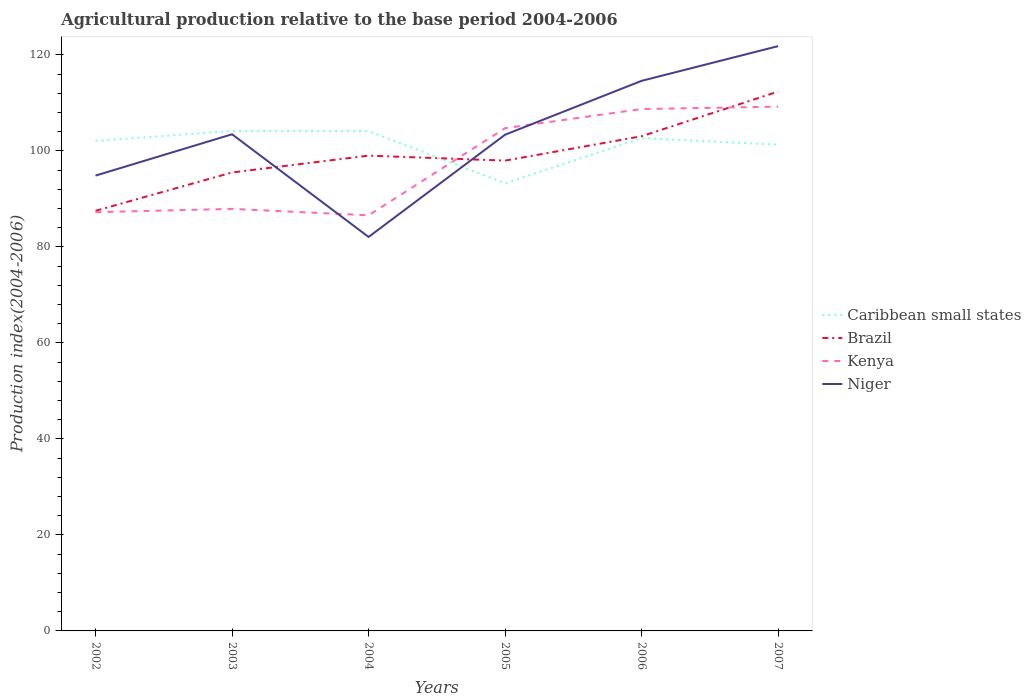How many different coloured lines are there?
Offer a terse response. 4. Across all years, what is the maximum agricultural production index in Brazil?
Offer a very short reply. 87.51. What is the total agricultural production index in Brazil in the graph?
Make the answer very short. -7.55. What is the difference between the highest and the second highest agricultural production index in Brazil?
Ensure brevity in your answer.  24.84. What is the difference between the highest and the lowest agricultural production index in Kenya?
Your answer should be compact. 3. Does the graph contain any zero values?
Offer a very short reply. No. How many legend labels are there?
Keep it short and to the point. 4. How are the legend labels stacked?
Provide a short and direct response. Vertical. What is the title of the graph?
Your answer should be compact. Agricultural production relative to the base period 2004-2006. Does "Burkina Faso" appear as one of the legend labels in the graph?
Offer a very short reply. No. What is the label or title of the Y-axis?
Give a very brief answer. Production index(2004-2006). What is the Production index(2004-2006) in Caribbean small states in 2002?
Provide a succinct answer. 102.07. What is the Production index(2004-2006) of Brazil in 2002?
Provide a short and direct response. 87.51. What is the Production index(2004-2006) in Kenya in 2002?
Provide a short and direct response. 87.22. What is the Production index(2004-2006) in Niger in 2002?
Give a very brief answer. 94.84. What is the Production index(2004-2006) of Caribbean small states in 2003?
Offer a terse response. 104.13. What is the Production index(2004-2006) of Brazil in 2003?
Make the answer very short. 95.49. What is the Production index(2004-2006) in Kenya in 2003?
Your answer should be very brief. 87.91. What is the Production index(2004-2006) in Niger in 2003?
Give a very brief answer. 103.45. What is the Production index(2004-2006) in Caribbean small states in 2004?
Your answer should be compact. 104.11. What is the Production index(2004-2006) of Kenya in 2004?
Provide a succinct answer. 86.57. What is the Production index(2004-2006) of Niger in 2004?
Make the answer very short. 82.06. What is the Production index(2004-2006) of Caribbean small states in 2005?
Ensure brevity in your answer.  93.24. What is the Production index(2004-2006) of Brazil in 2005?
Your response must be concise. 97.96. What is the Production index(2004-2006) in Kenya in 2005?
Offer a very short reply. 104.72. What is the Production index(2004-2006) of Niger in 2005?
Your response must be concise. 103.36. What is the Production index(2004-2006) of Caribbean small states in 2006?
Your answer should be very brief. 102.65. What is the Production index(2004-2006) of Brazil in 2006?
Your answer should be compact. 103.04. What is the Production index(2004-2006) of Kenya in 2006?
Give a very brief answer. 108.71. What is the Production index(2004-2006) of Niger in 2006?
Provide a short and direct response. 114.58. What is the Production index(2004-2006) in Caribbean small states in 2007?
Offer a terse response. 101.29. What is the Production index(2004-2006) of Brazil in 2007?
Your answer should be compact. 112.35. What is the Production index(2004-2006) in Kenya in 2007?
Your answer should be compact. 109.2. What is the Production index(2004-2006) of Niger in 2007?
Offer a terse response. 121.81. Across all years, what is the maximum Production index(2004-2006) of Caribbean small states?
Your response must be concise. 104.13. Across all years, what is the maximum Production index(2004-2006) in Brazil?
Offer a terse response. 112.35. Across all years, what is the maximum Production index(2004-2006) of Kenya?
Your response must be concise. 109.2. Across all years, what is the maximum Production index(2004-2006) in Niger?
Provide a short and direct response. 121.81. Across all years, what is the minimum Production index(2004-2006) in Caribbean small states?
Keep it short and to the point. 93.24. Across all years, what is the minimum Production index(2004-2006) in Brazil?
Your answer should be compact. 87.51. Across all years, what is the minimum Production index(2004-2006) of Kenya?
Give a very brief answer. 86.57. Across all years, what is the minimum Production index(2004-2006) of Niger?
Keep it short and to the point. 82.06. What is the total Production index(2004-2006) of Caribbean small states in the graph?
Ensure brevity in your answer.  607.49. What is the total Production index(2004-2006) of Brazil in the graph?
Make the answer very short. 595.35. What is the total Production index(2004-2006) in Kenya in the graph?
Make the answer very short. 584.33. What is the total Production index(2004-2006) of Niger in the graph?
Offer a terse response. 620.1. What is the difference between the Production index(2004-2006) in Caribbean small states in 2002 and that in 2003?
Make the answer very short. -2.06. What is the difference between the Production index(2004-2006) of Brazil in 2002 and that in 2003?
Keep it short and to the point. -7.98. What is the difference between the Production index(2004-2006) in Kenya in 2002 and that in 2003?
Provide a short and direct response. -0.69. What is the difference between the Production index(2004-2006) of Niger in 2002 and that in 2003?
Make the answer very short. -8.61. What is the difference between the Production index(2004-2006) of Caribbean small states in 2002 and that in 2004?
Provide a short and direct response. -2.04. What is the difference between the Production index(2004-2006) in Brazil in 2002 and that in 2004?
Ensure brevity in your answer.  -11.49. What is the difference between the Production index(2004-2006) in Kenya in 2002 and that in 2004?
Offer a very short reply. 0.65. What is the difference between the Production index(2004-2006) of Niger in 2002 and that in 2004?
Your answer should be compact. 12.78. What is the difference between the Production index(2004-2006) of Caribbean small states in 2002 and that in 2005?
Your response must be concise. 8.83. What is the difference between the Production index(2004-2006) in Brazil in 2002 and that in 2005?
Keep it short and to the point. -10.45. What is the difference between the Production index(2004-2006) of Kenya in 2002 and that in 2005?
Ensure brevity in your answer.  -17.5. What is the difference between the Production index(2004-2006) in Niger in 2002 and that in 2005?
Provide a short and direct response. -8.52. What is the difference between the Production index(2004-2006) in Caribbean small states in 2002 and that in 2006?
Your response must be concise. -0.58. What is the difference between the Production index(2004-2006) in Brazil in 2002 and that in 2006?
Give a very brief answer. -15.53. What is the difference between the Production index(2004-2006) in Kenya in 2002 and that in 2006?
Offer a terse response. -21.49. What is the difference between the Production index(2004-2006) of Niger in 2002 and that in 2006?
Your answer should be compact. -19.74. What is the difference between the Production index(2004-2006) in Caribbean small states in 2002 and that in 2007?
Your answer should be very brief. 0.78. What is the difference between the Production index(2004-2006) of Brazil in 2002 and that in 2007?
Your response must be concise. -24.84. What is the difference between the Production index(2004-2006) in Kenya in 2002 and that in 2007?
Give a very brief answer. -21.98. What is the difference between the Production index(2004-2006) in Niger in 2002 and that in 2007?
Ensure brevity in your answer.  -26.97. What is the difference between the Production index(2004-2006) in Caribbean small states in 2003 and that in 2004?
Make the answer very short. 0.02. What is the difference between the Production index(2004-2006) in Brazil in 2003 and that in 2004?
Provide a succinct answer. -3.51. What is the difference between the Production index(2004-2006) of Kenya in 2003 and that in 2004?
Offer a very short reply. 1.34. What is the difference between the Production index(2004-2006) of Niger in 2003 and that in 2004?
Your answer should be very brief. 21.39. What is the difference between the Production index(2004-2006) in Caribbean small states in 2003 and that in 2005?
Provide a short and direct response. 10.89. What is the difference between the Production index(2004-2006) in Brazil in 2003 and that in 2005?
Ensure brevity in your answer.  -2.47. What is the difference between the Production index(2004-2006) of Kenya in 2003 and that in 2005?
Keep it short and to the point. -16.81. What is the difference between the Production index(2004-2006) of Niger in 2003 and that in 2005?
Offer a very short reply. 0.09. What is the difference between the Production index(2004-2006) in Caribbean small states in 2003 and that in 2006?
Your response must be concise. 1.48. What is the difference between the Production index(2004-2006) of Brazil in 2003 and that in 2006?
Give a very brief answer. -7.55. What is the difference between the Production index(2004-2006) in Kenya in 2003 and that in 2006?
Make the answer very short. -20.8. What is the difference between the Production index(2004-2006) in Niger in 2003 and that in 2006?
Ensure brevity in your answer.  -11.13. What is the difference between the Production index(2004-2006) of Caribbean small states in 2003 and that in 2007?
Your answer should be compact. 2.84. What is the difference between the Production index(2004-2006) in Brazil in 2003 and that in 2007?
Provide a short and direct response. -16.86. What is the difference between the Production index(2004-2006) in Kenya in 2003 and that in 2007?
Ensure brevity in your answer.  -21.29. What is the difference between the Production index(2004-2006) in Niger in 2003 and that in 2007?
Your answer should be very brief. -18.36. What is the difference between the Production index(2004-2006) in Caribbean small states in 2004 and that in 2005?
Your response must be concise. 10.87. What is the difference between the Production index(2004-2006) in Kenya in 2004 and that in 2005?
Give a very brief answer. -18.15. What is the difference between the Production index(2004-2006) of Niger in 2004 and that in 2005?
Your answer should be compact. -21.3. What is the difference between the Production index(2004-2006) in Caribbean small states in 2004 and that in 2006?
Provide a short and direct response. 1.46. What is the difference between the Production index(2004-2006) in Brazil in 2004 and that in 2006?
Make the answer very short. -4.04. What is the difference between the Production index(2004-2006) of Kenya in 2004 and that in 2006?
Offer a terse response. -22.14. What is the difference between the Production index(2004-2006) in Niger in 2004 and that in 2006?
Keep it short and to the point. -32.52. What is the difference between the Production index(2004-2006) of Caribbean small states in 2004 and that in 2007?
Keep it short and to the point. 2.82. What is the difference between the Production index(2004-2006) of Brazil in 2004 and that in 2007?
Provide a succinct answer. -13.35. What is the difference between the Production index(2004-2006) in Kenya in 2004 and that in 2007?
Offer a terse response. -22.63. What is the difference between the Production index(2004-2006) of Niger in 2004 and that in 2007?
Your answer should be compact. -39.75. What is the difference between the Production index(2004-2006) in Caribbean small states in 2005 and that in 2006?
Ensure brevity in your answer.  -9.41. What is the difference between the Production index(2004-2006) of Brazil in 2005 and that in 2006?
Keep it short and to the point. -5.08. What is the difference between the Production index(2004-2006) in Kenya in 2005 and that in 2006?
Provide a succinct answer. -3.99. What is the difference between the Production index(2004-2006) of Niger in 2005 and that in 2006?
Offer a very short reply. -11.22. What is the difference between the Production index(2004-2006) in Caribbean small states in 2005 and that in 2007?
Offer a very short reply. -8.05. What is the difference between the Production index(2004-2006) in Brazil in 2005 and that in 2007?
Give a very brief answer. -14.39. What is the difference between the Production index(2004-2006) in Kenya in 2005 and that in 2007?
Keep it short and to the point. -4.48. What is the difference between the Production index(2004-2006) of Niger in 2005 and that in 2007?
Ensure brevity in your answer.  -18.45. What is the difference between the Production index(2004-2006) in Caribbean small states in 2006 and that in 2007?
Make the answer very short. 1.36. What is the difference between the Production index(2004-2006) in Brazil in 2006 and that in 2007?
Keep it short and to the point. -9.31. What is the difference between the Production index(2004-2006) in Kenya in 2006 and that in 2007?
Provide a short and direct response. -0.49. What is the difference between the Production index(2004-2006) in Niger in 2006 and that in 2007?
Offer a terse response. -7.23. What is the difference between the Production index(2004-2006) of Caribbean small states in 2002 and the Production index(2004-2006) of Brazil in 2003?
Offer a very short reply. 6.58. What is the difference between the Production index(2004-2006) of Caribbean small states in 2002 and the Production index(2004-2006) of Kenya in 2003?
Give a very brief answer. 14.16. What is the difference between the Production index(2004-2006) of Caribbean small states in 2002 and the Production index(2004-2006) of Niger in 2003?
Offer a very short reply. -1.38. What is the difference between the Production index(2004-2006) in Brazil in 2002 and the Production index(2004-2006) in Kenya in 2003?
Your response must be concise. -0.4. What is the difference between the Production index(2004-2006) in Brazil in 2002 and the Production index(2004-2006) in Niger in 2003?
Offer a terse response. -15.94. What is the difference between the Production index(2004-2006) of Kenya in 2002 and the Production index(2004-2006) of Niger in 2003?
Your response must be concise. -16.23. What is the difference between the Production index(2004-2006) of Caribbean small states in 2002 and the Production index(2004-2006) of Brazil in 2004?
Your answer should be very brief. 3.07. What is the difference between the Production index(2004-2006) in Caribbean small states in 2002 and the Production index(2004-2006) in Kenya in 2004?
Keep it short and to the point. 15.5. What is the difference between the Production index(2004-2006) of Caribbean small states in 2002 and the Production index(2004-2006) of Niger in 2004?
Give a very brief answer. 20.01. What is the difference between the Production index(2004-2006) of Brazil in 2002 and the Production index(2004-2006) of Kenya in 2004?
Keep it short and to the point. 0.94. What is the difference between the Production index(2004-2006) of Brazil in 2002 and the Production index(2004-2006) of Niger in 2004?
Make the answer very short. 5.45. What is the difference between the Production index(2004-2006) of Kenya in 2002 and the Production index(2004-2006) of Niger in 2004?
Give a very brief answer. 5.16. What is the difference between the Production index(2004-2006) of Caribbean small states in 2002 and the Production index(2004-2006) of Brazil in 2005?
Give a very brief answer. 4.11. What is the difference between the Production index(2004-2006) in Caribbean small states in 2002 and the Production index(2004-2006) in Kenya in 2005?
Your response must be concise. -2.65. What is the difference between the Production index(2004-2006) of Caribbean small states in 2002 and the Production index(2004-2006) of Niger in 2005?
Make the answer very short. -1.29. What is the difference between the Production index(2004-2006) in Brazil in 2002 and the Production index(2004-2006) in Kenya in 2005?
Your answer should be very brief. -17.21. What is the difference between the Production index(2004-2006) in Brazil in 2002 and the Production index(2004-2006) in Niger in 2005?
Make the answer very short. -15.85. What is the difference between the Production index(2004-2006) in Kenya in 2002 and the Production index(2004-2006) in Niger in 2005?
Ensure brevity in your answer.  -16.14. What is the difference between the Production index(2004-2006) in Caribbean small states in 2002 and the Production index(2004-2006) in Brazil in 2006?
Offer a terse response. -0.97. What is the difference between the Production index(2004-2006) in Caribbean small states in 2002 and the Production index(2004-2006) in Kenya in 2006?
Offer a very short reply. -6.64. What is the difference between the Production index(2004-2006) in Caribbean small states in 2002 and the Production index(2004-2006) in Niger in 2006?
Give a very brief answer. -12.51. What is the difference between the Production index(2004-2006) in Brazil in 2002 and the Production index(2004-2006) in Kenya in 2006?
Offer a terse response. -21.2. What is the difference between the Production index(2004-2006) in Brazil in 2002 and the Production index(2004-2006) in Niger in 2006?
Your answer should be compact. -27.07. What is the difference between the Production index(2004-2006) in Kenya in 2002 and the Production index(2004-2006) in Niger in 2006?
Keep it short and to the point. -27.36. What is the difference between the Production index(2004-2006) in Caribbean small states in 2002 and the Production index(2004-2006) in Brazil in 2007?
Offer a very short reply. -10.28. What is the difference between the Production index(2004-2006) in Caribbean small states in 2002 and the Production index(2004-2006) in Kenya in 2007?
Your answer should be very brief. -7.13. What is the difference between the Production index(2004-2006) in Caribbean small states in 2002 and the Production index(2004-2006) in Niger in 2007?
Provide a succinct answer. -19.74. What is the difference between the Production index(2004-2006) in Brazil in 2002 and the Production index(2004-2006) in Kenya in 2007?
Provide a succinct answer. -21.69. What is the difference between the Production index(2004-2006) in Brazil in 2002 and the Production index(2004-2006) in Niger in 2007?
Provide a short and direct response. -34.3. What is the difference between the Production index(2004-2006) of Kenya in 2002 and the Production index(2004-2006) of Niger in 2007?
Offer a terse response. -34.59. What is the difference between the Production index(2004-2006) of Caribbean small states in 2003 and the Production index(2004-2006) of Brazil in 2004?
Your response must be concise. 5.13. What is the difference between the Production index(2004-2006) in Caribbean small states in 2003 and the Production index(2004-2006) in Kenya in 2004?
Keep it short and to the point. 17.56. What is the difference between the Production index(2004-2006) in Caribbean small states in 2003 and the Production index(2004-2006) in Niger in 2004?
Keep it short and to the point. 22.07. What is the difference between the Production index(2004-2006) of Brazil in 2003 and the Production index(2004-2006) of Kenya in 2004?
Offer a very short reply. 8.92. What is the difference between the Production index(2004-2006) of Brazil in 2003 and the Production index(2004-2006) of Niger in 2004?
Your response must be concise. 13.43. What is the difference between the Production index(2004-2006) in Kenya in 2003 and the Production index(2004-2006) in Niger in 2004?
Ensure brevity in your answer.  5.85. What is the difference between the Production index(2004-2006) of Caribbean small states in 2003 and the Production index(2004-2006) of Brazil in 2005?
Give a very brief answer. 6.17. What is the difference between the Production index(2004-2006) in Caribbean small states in 2003 and the Production index(2004-2006) in Kenya in 2005?
Offer a very short reply. -0.59. What is the difference between the Production index(2004-2006) in Caribbean small states in 2003 and the Production index(2004-2006) in Niger in 2005?
Provide a succinct answer. 0.77. What is the difference between the Production index(2004-2006) in Brazil in 2003 and the Production index(2004-2006) in Kenya in 2005?
Your response must be concise. -9.23. What is the difference between the Production index(2004-2006) of Brazil in 2003 and the Production index(2004-2006) of Niger in 2005?
Your answer should be very brief. -7.87. What is the difference between the Production index(2004-2006) of Kenya in 2003 and the Production index(2004-2006) of Niger in 2005?
Offer a very short reply. -15.45. What is the difference between the Production index(2004-2006) of Caribbean small states in 2003 and the Production index(2004-2006) of Brazil in 2006?
Make the answer very short. 1.09. What is the difference between the Production index(2004-2006) in Caribbean small states in 2003 and the Production index(2004-2006) in Kenya in 2006?
Keep it short and to the point. -4.58. What is the difference between the Production index(2004-2006) in Caribbean small states in 2003 and the Production index(2004-2006) in Niger in 2006?
Give a very brief answer. -10.45. What is the difference between the Production index(2004-2006) in Brazil in 2003 and the Production index(2004-2006) in Kenya in 2006?
Make the answer very short. -13.22. What is the difference between the Production index(2004-2006) of Brazil in 2003 and the Production index(2004-2006) of Niger in 2006?
Offer a terse response. -19.09. What is the difference between the Production index(2004-2006) of Kenya in 2003 and the Production index(2004-2006) of Niger in 2006?
Your answer should be compact. -26.67. What is the difference between the Production index(2004-2006) of Caribbean small states in 2003 and the Production index(2004-2006) of Brazil in 2007?
Your response must be concise. -8.22. What is the difference between the Production index(2004-2006) in Caribbean small states in 2003 and the Production index(2004-2006) in Kenya in 2007?
Keep it short and to the point. -5.07. What is the difference between the Production index(2004-2006) of Caribbean small states in 2003 and the Production index(2004-2006) of Niger in 2007?
Offer a very short reply. -17.68. What is the difference between the Production index(2004-2006) in Brazil in 2003 and the Production index(2004-2006) in Kenya in 2007?
Make the answer very short. -13.71. What is the difference between the Production index(2004-2006) of Brazil in 2003 and the Production index(2004-2006) of Niger in 2007?
Make the answer very short. -26.32. What is the difference between the Production index(2004-2006) of Kenya in 2003 and the Production index(2004-2006) of Niger in 2007?
Provide a short and direct response. -33.9. What is the difference between the Production index(2004-2006) of Caribbean small states in 2004 and the Production index(2004-2006) of Brazil in 2005?
Keep it short and to the point. 6.15. What is the difference between the Production index(2004-2006) in Caribbean small states in 2004 and the Production index(2004-2006) in Kenya in 2005?
Offer a terse response. -0.61. What is the difference between the Production index(2004-2006) of Caribbean small states in 2004 and the Production index(2004-2006) of Niger in 2005?
Offer a very short reply. 0.75. What is the difference between the Production index(2004-2006) of Brazil in 2004 and the Production index(2004-2006) of Kenya in 2005?
Make the answer very short. -5.72. What is the difference between the Production index(2004-2006) in Brazil in 2004 and the Production index(2004-2006) in Niger in 2005?
Your answer should be very brief. -4.36. What is the difference between the Production index(2004-2006) in Kenya in 2004 and the Production index(2004-2006) in Niger in 2005?
Your answer should be compact. -16.79. What is the difference between the Production index(2004-2006) of Caribbean small states in 2004 and the Production index(2004-2006) of Brazil in 2006?
Keep it short and to the point. 1.07. What is the difference between the Production index(2004-2006) in Caribbean small states in 2004 and the Production index(2004-2006) in Kenya in 2006?
Keep it short and to the point. -4.6. What is the difference between the Production index(2004-2006) of Caribbean small states in 2004 and the Production index(2004-2006) of Niger in 2006?
Provide a succinct answer. -10.47. What is the difference between the Production index(2004-2006) of Brazil in 2004 and the Production index(2004-2006) of Kenya in 2006?
Your response must be concise. -9.71. What is the difference between the Production index(2004-2006) in Brazil in 2004 and the Production index(2004-2006) in Niger in 2006?
Offer a terse response. -15.58. What is the difference between the Production index(2004-2006) in Kenya in 2004 and the Production index(2004-2006) in Niger in 2006?
Offer a very short reply. -28.01. What is the difference between the Production index(2004-2006) in Caribbean small states in 2004 and the Production index(2004-2006) in Brazil in 2007?
Provide a short and direct response. -8.24. What is the difference between the Production index(2004-2006) of Caribbean small states in 2004 and the Production index(2004-2006) of Kenya in 2007?
Your response must be concise. -5.09. What is the difference between the Production index(2004-2006) in Caribbean small states in 2004 and the Production index(2004-2006) in Niger in 2007?
Your response must be concise. -17.7. What is the difference between the Production index(2004-2006) in Brazil in 2004 and the Production index(2004-2006) in Kenya in 2007?
Your answer should be very brief. -10.2. What is the difference between the Production index(2004-2006) of Brazil in 2004 and the Production index(2004-2006) of Niger in 2007?
Offer a terse response. -22.81. What is the difference between the Production index(2004-2006) in Kenya in 2004 and the Production index(2004-2006) in Niger in 2007?
Your answer should be very brief. -35.24. What is the difference between the Production index(2004-2006) of Caribbean small states in 2005 and the Production index(2004-2006) of Brazil in 2006?
Your answer should be compact. -9.8. What is the difference between the Production index(2004-2006) of Caribbean small states in 2005 and the Production index(2004-2006) of Kenya in 2006?
Ensure brevity in your answer.  -15.47. What is the difference between the Production index(2004-2006) in Caribbean small states in 2005 and the Production index(2004-2006) in Niger in 2006?
Ensure brevity in your answer.  -21.34. What is the difference between the Production index(2004-2006) of Brazil in 2005 and the Production index(2004-2006) of Kenya in 2006?
Your answer should be compact. -10.75. What is the difference between the Production index(2004-2006) of Brazil in 2005 and the Production index(2004-2006) of Niger in 2006?
Your response must be concise. -16.62. What is the difference between the Production index(2004-2006) in Kenya in 2005 and the Production index(2004-2006) in Niger in 2006?
Provide a succinct answer. -9.86. What is the difference between the Production index(2004-2006) of Caribbean small states in 2005 and the Production index(2004-2006) of Brazil in 2007?
Give a very brief answer. -19.11. What is the difference between the Production index(2004-2006) in Caribbean small states in 2005 and the Production index(2004-2006) in Kenya in 2007?
Provide a short and direct response. -15.96. What is the difference between the Production index(2004-2006) in Caribbean small states in 2005 and the Production index(2004-2006) in Niger in 2007?
Your answer should be compact. -28.57. What is the difference between the Production index(2004-2006) of Brazil in 2005 and the Production index(2004-2006) of Kenya in 2007?
Offer a very short reply. -11.24. What is the difference between the Production index(2004-2006) in Brazil in 2005 and the Production index(2004-2006) in Niger in 2007?
Your answer should be very brief. -23.85. What is the difference between the Production index(2004-2006) of Kenya in 2005 and the Production index(2004-2006) of Niger in 2007?
Provide a short and direct response. -17.09. What is the difference between the Production index(2004-2006) of Caribbean small states in 2006 and the Production index(2004-2006) of Brazil in 2007?
Your response must be concise. -9.7. What is the difference between the Production index(2004-2006) of Caribbean small states in 2006 and the Production index(2004-2006) of Kenya in 2007?
Ensure brevity in your answer.  -6.55. What is the difference between the Production index(2004-2006) in Caribbean small states in 2006 and the Production index(2004-2006) in Niger in 2007?
Your answer should be very brief. -19.16. What is the difference between the Production index(2004-2006) in Brazil in 2006 and the Production index(2004-2006) in Kenya in 2007?
Ensure brevity in your answer.  -6.16. What is the difference between the Production index(2004-2006) of Brazil in 2006 and the Production index(2004-2006) of Niger in 2007?
Your answer should be very brief. -18.77. What is the difference between the Production index(2004-2006) of Kenya in 2006 and the Production index(2004-2006) of Niger in 2007?
Make the answer very short. -13.1. What is the average Production index(2004-2006) in Caribbean small states per year?
Offer a terse response. 101.25. What is the average Production index(2004-2006) in Brazil per year?
Your answer should be compact. 99.22. What is the average Production index(2004-2006) of Kenya per year?
Your answer should be very brief. 97.39. What is the average Production index(2004-2006) in Niger per year?
Make the answer very short. 103.35. In the year 2002, what is the difference between the Production index(2004-2006) of Caribbean small states and Production index(2004-2006) of Brazil?
Ensure brevity in your answer.  14.56. In the year 2002, what is the difference between the Production index(2004-2006) of Caribbean small states and Production index(2004-2006) of Kenya?
Provide a short and direct response. 14.85. In the year 2002, what is the difference between the Production index(2004-2006) in Caribbean small states and Production index(2004-2006) in Niger?
Your answer should be very brief. 7.23. In the year 2002, what is the difference between the Production index(2004-2006) in Brazil and Production index(2004-2006) in Kenya?
Your answer should be compact. 0.29. In the year 2002, what is the difference between the Production index(2004-2006) of Brazil and Production index(2004-2006) of Niger?
Make the answer very short. -7.33. In the year 2002, what is the difference between the Production index(2004-2006) in Kenya and Production index(2004-2006) in Niger?
Ensure brevity in your answer.  -7.62. In the year 2003, what is the difference between the Production index(2004-2006) of Caribbean small states and Production index(2004-2006) of Brazil?
Offer a very short reply. 8.64. In the year 2003, what is the difference between the Production index(2004-2006) of Caribbean small states and Production index(2004-2006) of Kenya?
Make the answer very short. 16.22. In the year 2003, what is the difference between the Production index(2004-2006) of Caribbean small states and Production index(2004-2006) of Niger?
Your answer should be very brief. 0.68. In the year 2003, what is the difference between the Production index(2004-2006) of Brazil and Production index(2004-2006) of Kenya?
Give a very brief answer. 7.58. In the year 2003, what is the difference between the Production index(2004-2006) of Brazil and Production index(2004-2006) of Niger?
Offer a very short reply. -7.96. In the year 2003, what is the difference between the Production index(2004-2006) in Kenya and Production index(2004-2006) in Niger?
Offer a terse response. -15.54. In the year 2004, what is the difference between the Production index(2004-2006) of Caribbean small states and Production index(2004-2006) of Brazil?
Your answer should be very brief. 5.11. In the year 2004, what is the difference between the Production index(2004-2006) in Caribbean small states and Production index(2004-2006) in Kenya?
Ensure brevity in your answer.  17.54. In the year 2004, what is the difference between the Production index(2004-2006) of Caribbean small states and Production index(2004-2006) of Niger?
Provide a short and direct response. 22.05. In the year 2004, what is the difference between the Production index(2004-2006) in Brazil and Production index(2004-2006) in Kenya?
Make the answer very short. 12.43. In the year 2004, what is the difference between the Production index(2004-2006) of Brazil and Production index(2004-2006) of Niger?
Offer a very short reply. 16.94. In the year 2004, what is the difference between the Production index(2004-2006) in Kenya and Production index(2004-2006) in Niger?
Keep it short and to the point. 4.51. In the year 2005, what is the difference between the Production index(2004-2006) in Caribbean small states and Production index(2004-2006) in Brazil?
Offer a very short reply. -4.72. In the year 2005, what is the difference between the Production index(2004-2006) of Caribbean small states and Production index(2004-2006) of Kenya?
Offer a terse response. -11.48. In the year 2005, what is the difference between the Production index(2004-2006) in Caribbean small states and Production index(2004-2006) in Niger?
Give a very brief answer. -10.12. In the year 2005, what is the difference between the Production index(2004-2006) in Brazil and Production index(2004-2006) in Kenya?
Provide a short and direct response. -6.76. In the year 2005, what is the difference between the Production index(2004-2006) in Brazil and Production index(2004-2006) in Niger?
Offer a terse response. -5.4. In the year 2005, what is the difference between the Production index(2004-2006) in Kenya and Production index(2004-2006) in Niger?
Offer a terse response. 1.36. In the year 2006, what is the difference between the Production index(2004-2006) of Caribbean small states and Production index(2004-2006) of Brazil?
Offer a very short reply. -0.39. In the year 2006, what is the difference between the Production index(2004-2006) of Caribbean small states and Production index(2004-2006) of Kenya?
Your answer should be compact. -6.06. In the year 2006, what is the difference between the Production index(2004-2006) in Caribbean small states and Production index(2004-2006) in Niger?
Offer a terse response. -11.93. In the year 2006, what is the difference between the Production index(2004-2006) in Brazil and Production index(2004-2006) in Kenya?
Make the answer very short. -5.67. In the year 2006, what is the difference between the Production index(2004-2006) in Brazil and Production index(2004-2006) in Niger?
Your response must be concise. -11.54. In the year 2006, what is the difference between the Production index(2004-2006) of Kenya and Production index(2004-2006) of Niger?
Give a very brief answer. -5.87. In the year 2007, what is the difference between the Production index(2004-2006) in Caribbean small states and Production index(2004-2006) in Brazil?
Ensure brevity in your answer.  -11.06. In the year 2007, what is the difference between the Production index(2004-2006) in Caribbean small states and Production index(2004-2006) in Kenya?
Offer a terse response. -7.91. In the year 2007, what is the difference between the Production index(2004-2006) in Caribbean small states and Production index(2004-2006) in Niger?
Provide a succinct answer. -20.52. In the year 2007, what is the difference between the Production index(2004-2006) of Brazil and Production index(2004-2006) of Kenya?
Your response must be concise. 3.15. In the year 2007, what is the difference between the Production index(2004-2006) of Brazil and Production index(2004-2006) of Niger?
Offer a terse response. -9.46. In the year 2007, what is the difference between the Production index(2004-2006) of Kenya and Production index(2004-2006) of Niger?
Give a very brief answer. -12.61. What is the ratio of the Production index(2004-2006) in Caribbean small states in 2002 to that in 2003?
Ensure brevity in your answer.  0.98. What is the ratio of the Production index(2004-2006) in Brazil in 2002 to that in 2003?
Your response must be concise. 0.92. What is the ratio of the Production index(2004-2006) of Niger in 2002 to that in 2003?
Your answer should be very brief. 0.92. What is the ratio of the Production index(2004-2006) in Caribbean small states in 2002 to that in 2004?
Offer a very short reply. 0.98. What is the ratio of the Production index(2004-2006) of Brazil in 2002 to that in 2004?
Your response must be concise. 0.88. What is the ratio of the Production index(2004-2006) in Kenya in 2002 to that in 2004?
Keep it short and to the point. 1.01. What is the ratio of the Production index(2004-2006) in Niger in 2002 to that in 2004?
Offer a terse response. 1.16. What is the ratio of the Production index(2004-2006) in Caribbean small states in 2002 to that in 2005?
Provide a succinct answer. 1.09. What is the ratio of the Production index(2004-2006) of Brazil in 2002 to that in 2005?
Your answer should be compact. 0.89. What is the ratio of the Production index(2004-2006) in Kenya in 2002 to that in 2005?
Provide a short and direct response. 0.83. What is the ratio of the Production index(2004-2006) in Niger in 2002 to that in 2005?
Give a very brief answer. 0.92. What is the ratio of the Production index(2004-2006) in Brazil in 2002 to that in 2006?
Ensure brevity in your answer.  0.85. What is the ratio of the Production index(2004-2006) in Kenya in 2002 to that in 2006?
Offer a terse response. 0.8. What is the ratio of the Production index(2004-2006) in Niger in 2002 to that in 2006?
Provide a succinct answer. 0.83. What is the ratio of the Production index(2004-2006) in Caribbean small states in 2002 to that in 2007?
Your response must be concise. 1.01. What is the ratio of the Production index(2004-2006) of Brazil in 2002 to that in 2007?
Offer a terse response. 0.78. What is the ratio of the Production index(2004-2006) in Kenya in 2002 to that in 2007?
Your answer should be very brief. 0.8. What is the ratio of the Production index(2004-2006) of Niger in 2002 to that in 2007?
Your answer should be compact. 0.78. What is the ratio of the Production index(2004-2006) of Brazil in 2003 to that in 2004?
Give a very brief answer. 0.96. What is the ratio of the Production index(2004-2006) of Kenya in 2003 to that in 2004?
Keep it short and to the point. 1.02. What is the ratio of the Production index(2004-2006) in Niger in 2003 to that in 2004?
Provide a short and direct response. 1.26. What is the ratio of the Production index(2004-2006) in Caribbean small states in 2003 to that in 2005?
Ensure brevity in your answer.  1.12. What is the ratio of the Production index(2004-2006) in Brazil in 2003 to that in 2005?
Ensure brevity in your answer.  0.97. What is the ratio of the Production index(2004-2006) of Kenya in 2003 to that in 2005?
Give a very brief answer. 0.84. What is the ratio of the Production index(2004-2006) in Caribbean small states in 2003 to that in 2006?
Provide a short and direct response. 1.01. What is the ratio of the Production index(2004-2006) in Brazil in 2003 to that in 2006?
Offer a terse response. 0.93. What is the ratio of the Production index(2004-2006) in Kenya in 2003 to that in 2006?
Your answer should be very brief. 0.81. What is the ratio of the Production index(2004-2006) in Niger in 2003 to that in 2006?
Ensure brevity in your answer.  0.9. What is the ratio of the Production index(2004-2006) of Caribbean small states in 2003 to that in 2007?
Ensure brevity in your answer.  1.03. What is the ratio of the Production index(2004-2006) of Brazil in 2003 to that in 2007?
Give a very brief answer. 0.85. What is the ratio of the Production index(2004-2006) of Kenya in 2003 to that in 2007?
Keep it short and to the point. 0.81. What is the ratio of the Production index(2004-2006) in Niger in 2003 to that in 2007?
Provide a short and direct response. 0.85. What is the ratio of the Production index(2004-2006) in Caribbean small states in 2004 to that in 2005?
Your answer should be very brief. 1.12. What is the ratio of the Production index(2004-2006) in Brazil in 2004 to that in 2005?
Offer a very short reply. 1.01. What is the ratio of the Production index(2004-2006) in Kenya in 2004 to that in 2005?
Keep it short and to the point. 0.83. What is the ratio of the Production index(2004-2006) of Niger in 2004 to that in 2005?
Provide a short and direct response. 0.79. What is the ratio of the Production index(2004-2006) in Caribbean small states in 2004 to that in 2006?
Your answer should be very brief. 1.01. What is the ratio of the Production index(2004-2006) in Brazil in 2004 to that in 2006?
Offer a terse response. 0.96. What is the ratio of the Production index(2004-2006) in Kenya in 2004 to that in 2006?
Keep it short and to the point. 0.8. What is the ratio of the Production index(2004-2006) of Niger in 2004 to that in 2006?
Offer a very short reply. 0.72. What is the ratio of the Production index(2004-2006) of Caribbean small states in 2004 to that in 2007?
Offer a very short reply. 1.03. What is the ratio of the Production index(2004-2006) of Brazil in 2004 to that in 2007?
Your answer should be very brief. 0.88. What is the ratio of the Production index(2004-2006) in Kenya in 2004 to that in 2007?
Offer a very short reply. 0.79. What is the ratio of the Production index(2004-2006) of Niger in 2004 to that in 2007?
Offer a very short reply. 0.67. What is the ratio of the Production index(2004-2006) of Caribbean small states in 2005 to that in 2006?
Provide a short and direct response. 0.91. What is the ratio of the Production index(2004-2006) in Brazil in 2005 to that in 2006?
Offer a very short reply. 0.95. What is the ratio of the Production index(2004-2006) of Kenya in 2005 to that in 2006?
Keep it short and to the point. 0.96. What is the ratio of the Production index(2004-2006) of Niger in 2005 to that in 2006?
Keep it short and to the point. 0.9. What is the ratio of the Production index(2004-2006) of Caribbean small states in 2005 to that in 2007?
Provide a short and direct response. 0.92. What is the ratio of the Production index(2004-2006) of Brazil in 2005 to that in 2007?
Offer a terse response. 0.87. What is the ratio of the Production index(2004-2006) in Kenya in 2005 to that in 2007?
Keep it short and to the point. 0.96. What is the ratio of the Production index(2004-2006) of Niger in 2005 to that in 2007?
Offer a very short reply. 0.85. What is the ratio of the Production index(2004-2006) of Caribbean small states in 2006 to that in 2007?
Offer a very short reply. 1.01. What is the ratio of the Production index(2004-2006) in Brazil in 2006 to that in 2007?
Provide a succinct answer. 0.92. What is the ratio of the Production index(2004-2006) of Niger in 2006 to that in 2007?
Offer a very short reply. 0.94. What is the difference between the highest and the second highest Production index(2004-2006) of Caribbean small states?
Offer a very short reply. 0.02. What is the difference between the highest and the second highest Production index(2004-2006) in Brazil?
Your response must be concise. 9.31. What is the difference between the highest and the second highest Production index(2004-2006) of Kenya?
Your answer should be compact. 0.49. What is the difference between the highest and the second highest Production index(2004-2006) of Niger?
Your answer should be compact. 7.23. What is the difference between the highest and the lowest Production index(2004-2006) of Caribbean small states?
Keep it short and to the point. 10.89. What is the difference between the highest and the lowest Production index(2004-2006) in Brazil?
Offer a very short reply. 24.84. What is the difference between the highest and the lowest Production index(2004-2006) of Kenya?
Offer a terse response. 22.63. What is the difference between the highest and the lowest Production index(2004-2006) in Niger?
Offer a very short reply. 39.75. 